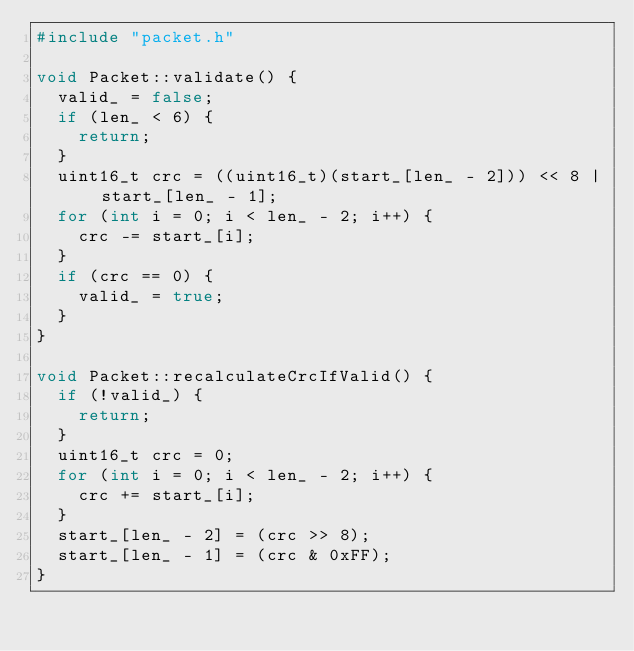<code> <loc_0><loc_0><loc_500><loc_500><_C++_>#include "packet.h"

void Packet::validate() {
  valid_ = false;
  if (len_ < 6) {
    return;
  }
  uint16_t crc = ((uint16_t)(start_[len_ - 2])) << 8 | start_[len_ - 1];
  for (int i = 0; i < len_ - 2; i++) {
    crc -= start_[i];
  }
  if (crc == 0) {
    valid_ = true;
  }
}

void Packet::recalculateCrcIfValid() {
  if (!valid_) {
    return;
  }
  uint16_t crc = 0;
  for (int i = 0; i < len_ - 2; i++) {
    crc += start_[i];
  }
  start_[len_ - 2] = (crc >> 8);
  start_[len_ - 1] = (crc & 0xFF);
}</code> 